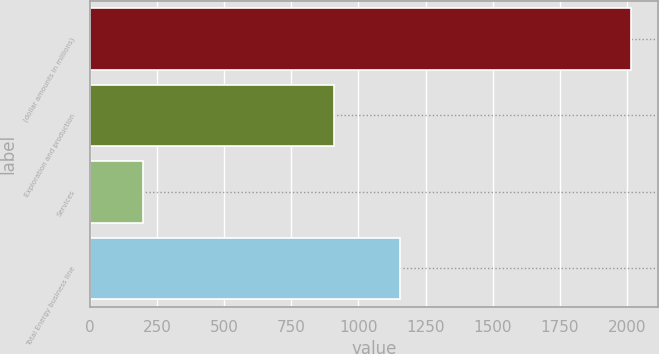Convert chart to OTSL. <chart><loc_0><loc_0><loc_500><loc_500><bar_chart><fcel>(dollar amounts in millions)<fcel>Exploration and production<fcel>Services<fcel>Total Energy business line<nl><fcel>2016<fcel>910<fcel>200<fcel>1155<nl></chart> 